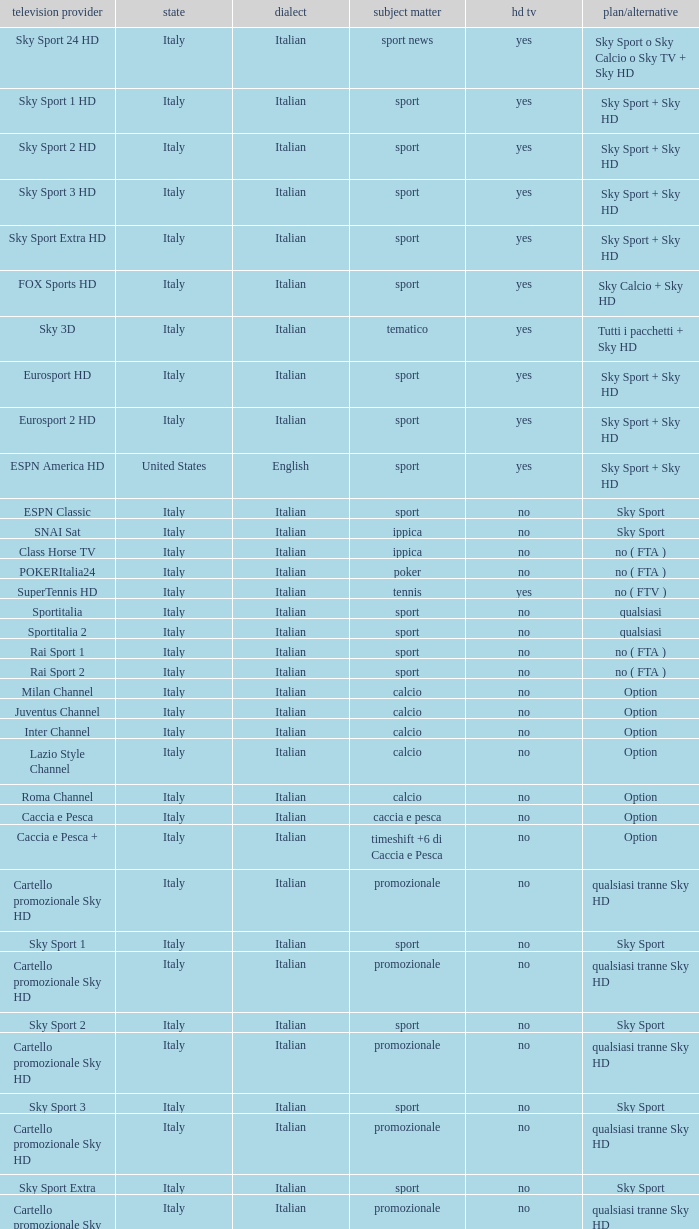What is Country, when Television Service is Eurosport 2? Italy. 